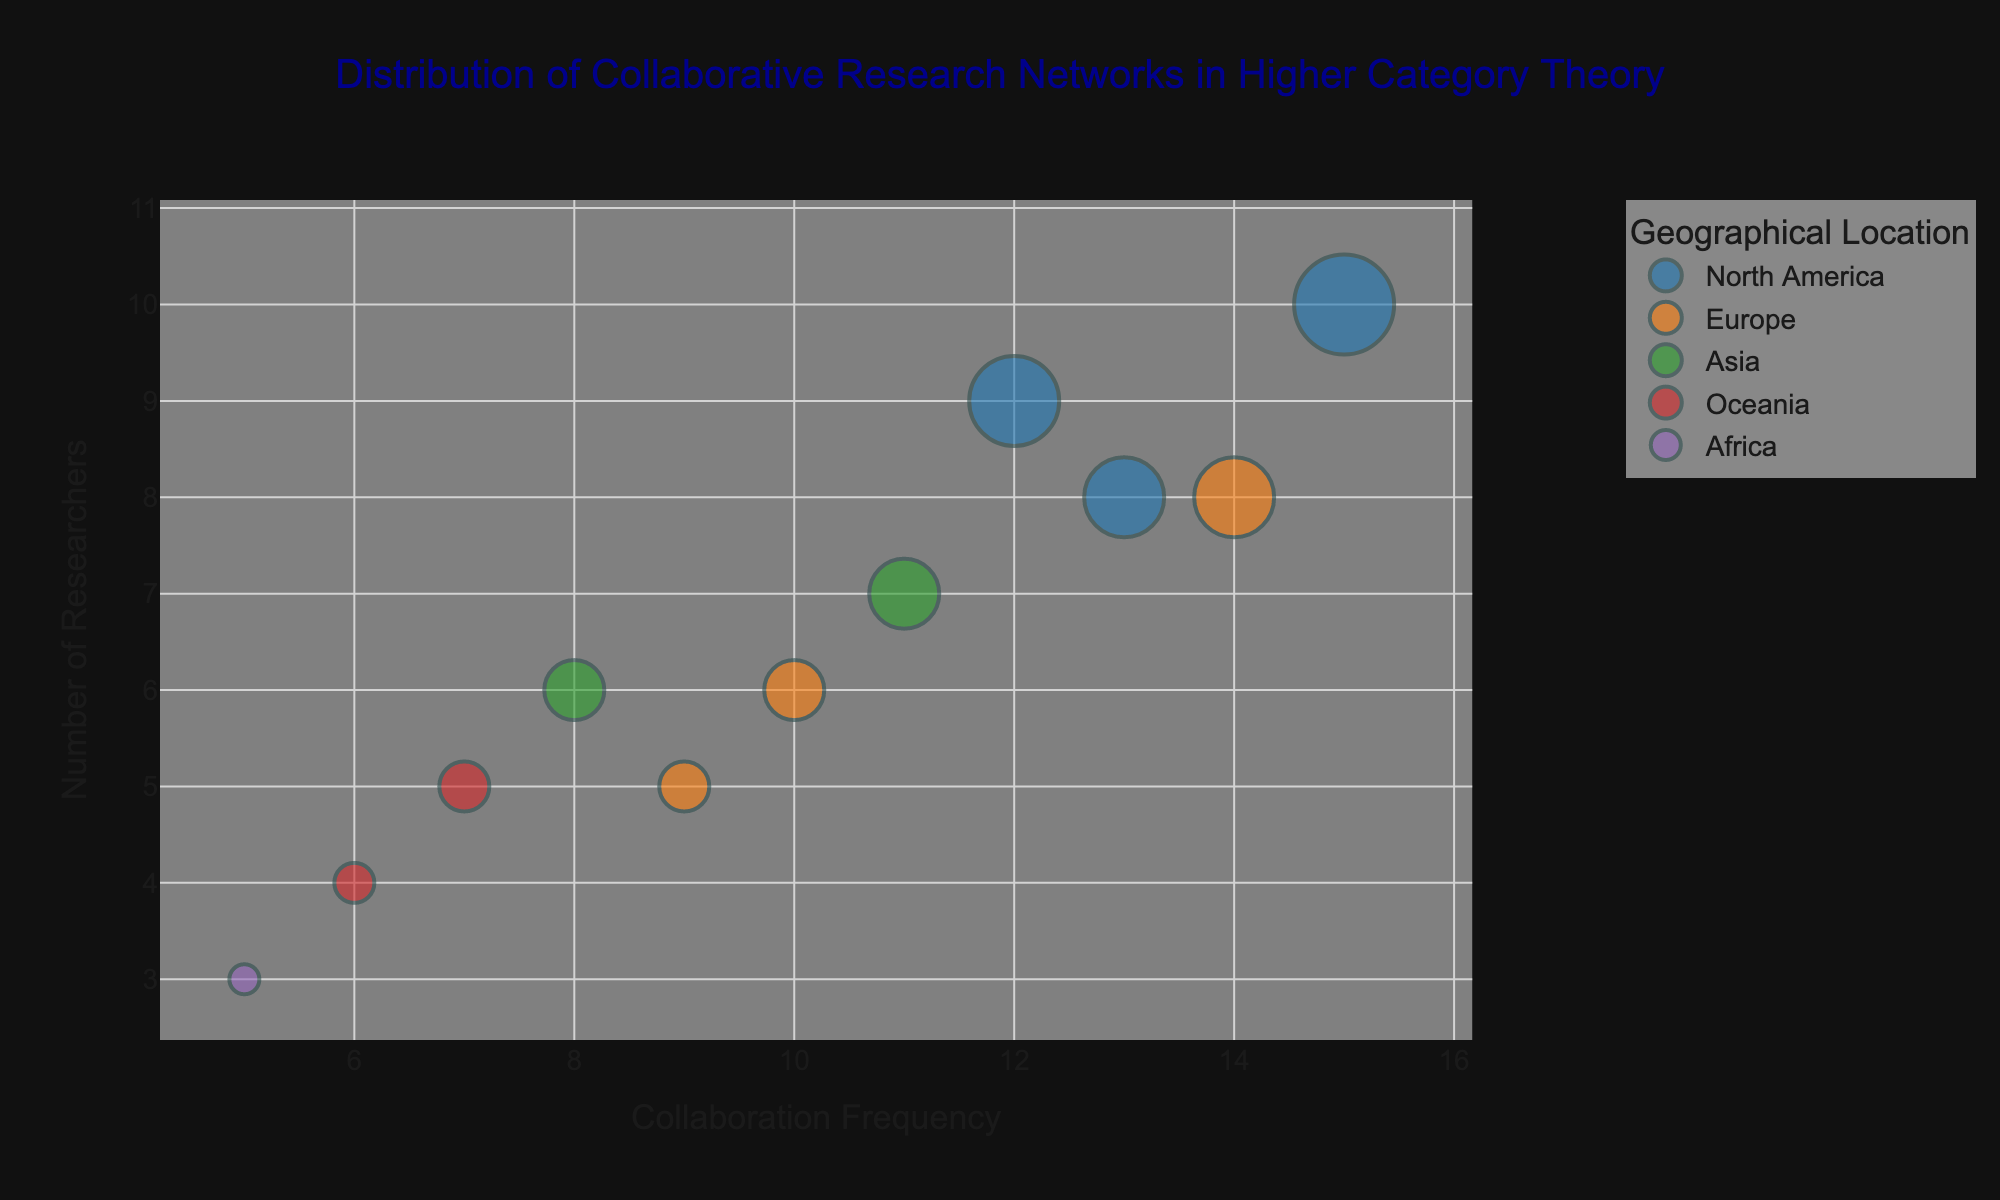Which institution has the highest Collaboration Frequency? By examining the x-axis, identify the bubble with the furthest right position. The Massachusetts Institute of Technology has a Collaboration Frequency of 15, which is the highest in the dataset.
Answer: Massachusetts Institute of Technology How many researchers are involved in the collaborative network at the University of Cambridge? Locate the University of Cambridge bubble and refer to its position on the y-axis. The bubble is placed at 6 on the Number of Researchers axis.
Answer: 6 Which geographical location has the highest number of institutions shown in the figure? Count the number of bubbles grouped by Geographical Location. North America has the highest count with three institutions: MIT, Harvard University, and UC Berkeley.
Answer: North America What is the average Number of Researchers for institutions in Oceania? Identify the Number of Researchers for institutions in Oceania: Australian National University (5) and University of Sydney (4). The average is (5 + 4) / 2 = 4.5.
Answer: 4.5 Which type of institution appears most frequently in the figure, and how many times does it appear? Count the number of occurrences of each institution type in the hover information. Universities appear 9 times, which is more frequent than Research Institutes (1 time).
Answer: University, 9 times Compare the Collaboration Frequency between Massachusetts Institute of Technology and University of Cape Town. Which one has a higher frequency and by how much? Examine the x-axis position of each bubble. MIT has a frequency of 15, and University of Cape Town has 5. The difference is 15 - 5 = 10.
Answer: MIT, by 10 What is the radius of the bubble for Harvard University if the size is proportional to the Number of Researchers? Harvard University has 8 researchers, and each researcher represents 5 units of bubble size. Thus, the radius is 8 * 5 = 40 units.
Answer: 40 units Which institution in Europe has the highest Collaboration Frequency, and what is the frequency? Examine the x-axis positions of the bubbles for European institutions. Max Planck Institute for Mathematics has the highest frequency with a value of 14.
Answer: Max Planck Institute for Mathematics, 14 How does the Number of Researchers at Kyoto University compare to the number at Shanghai Jiao Tong University? Identify the y-axis position of each bubble. Kyoto University has 7 researchers and Shanghai Jiao Tong University has 6. Kyoto University has 1 more researcher.
Answer: Kyoto University has 1 more researcher 